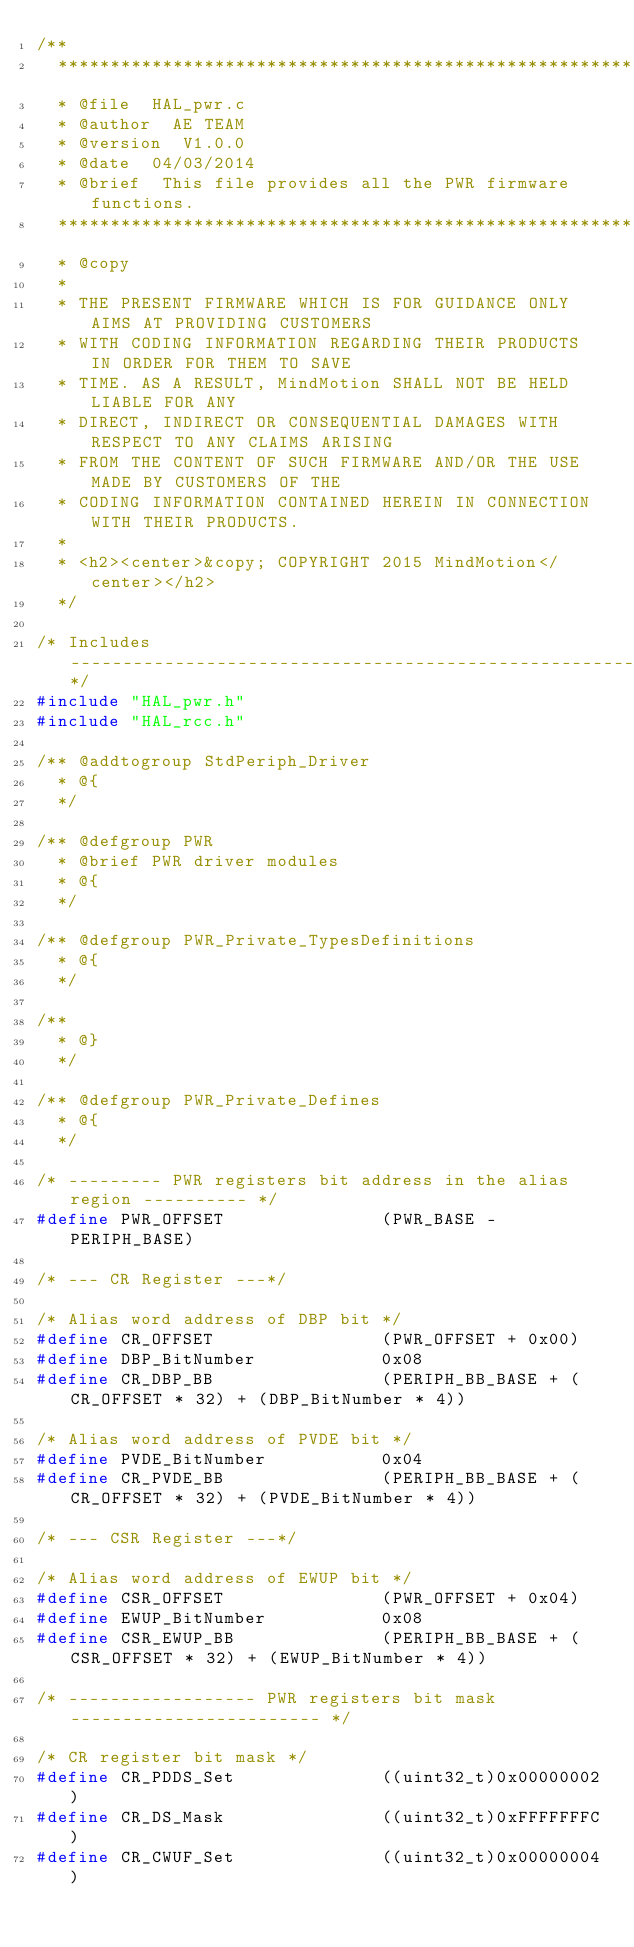Convert code to text. <code><loc_0><loc_0><loc_500><loc_500><_C_>/**
  ******************************************************************************
  * @file  HAL_pwr.c
  * @author  AE TEAM
  * @version  V1.0.0
  * @date  04/03/2014
  * @brief  This file provides all the PWR firmware functions.
  ******************************************************************************
  * @copy
  *
  * THE PRESENT FIRMWARE WHICH IS FOR GUIDANCE ONLY AIMS AT PROVIDING CUSTOMERS
  * WITH CODING INFORMATION REGARDING THEIR PRODUCTS IN ORDER FOR THEM TO SAVE
  * TIME. AS A RESULT, MindMotion SHALL NOT BE HELD LIABLE FOR ANY
  * DIRECT, INDIRECT OR CONSEQUENTIAL DAMAGES WITH RESPECT TO ANY CLAIMS ARISING
  * FROM THE CONTENT OF SUCH FIRMWARE AND/OR THE USE MADE BY CUSTOMERS OF THE
  * CODING INFORMATION CONTAINED HEREIN IN CONNECTION WITH THEIR PRODUCTS.
  *
  * <h2><center>&copy; COPYRIGHT 2015 MindMotion</center></h2>
  */ 

/* Includes ------------------------------------------------------------------*/
#include "HAL_pwr.h"
#include "HAL_rcc.h"

/** @addtogroup StdPeriph_Driver
  * @{
  */

/** @defgroup PWR 
  * @brief PWR driver modules
  * @{
  */ 

/** @defgroup PWR_Private_TypesDefinitions
  * @{
  */

/**
  * @}
  */

/** @defgroup PWR_Private_Defines
  * @{
  */

/* --------- PWR registers bit address in the alias region ---------- */
#define PWR_OFFSET               (PWR_BASE - PERIPH_BASE)

/* --- CR Register ---*/

/* Alias word address of DBP bit */
#define CR_OFFSET                (PWR_OFFSET + 0x00)
#define DBP_BitNumber            0x08
#define CR_DBP_BB                (PERIPH_BB_BASE + (CR_OFFSET * 32) + (DBP_BitNumber * 4))

/* Alias word address of PVDE bit */
#define PVDE_BitNumber           0x04
#define CR_PVDE_BB               (PERIPH_BB_BASE + (CR_OFFSET * 32) + (PVDE_BitNumber * 4))

/* --- CSR Register ---*/

/* Alias word address of EWUP bit */
#define CSR_OFFSET               (PWR_OFFSET + 0x04)
#define EWUP_BitNumber           0x08
#define CSR_EWUP_BB              (PERIPH_BB_BASE + (CSR_OFFSET * 32) + (EWUP_BitNumber * 4))

/* ------------------ PWR registers bit mask ------------------------ */

/* CR register bit mask */
#define CR_PDDS_Set              ((uint32_t)0x00000002)
#define CR_DS_Mask               ((uint32_t)0xFFFFFFFC)
#define CR_CWUF_Set              ((uint32_t)0x00000004)</code> 